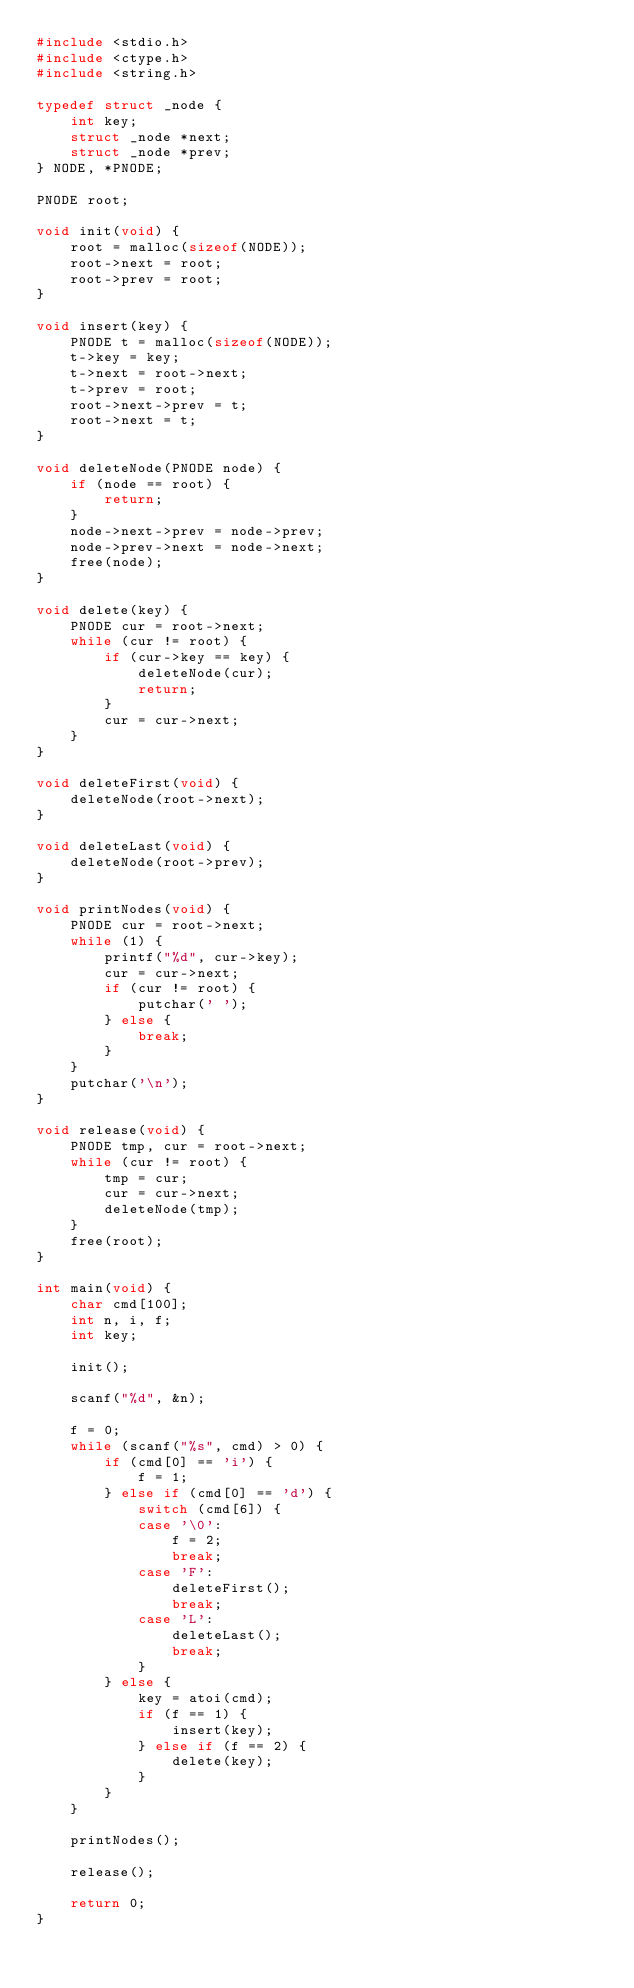<code> <loc_0><loc_0><loc_500><loc_500><_C_>#include <stdio.h>
#include <ctype.h>
#include <string.h>

typedef struct _node {
	int key;
	struct _node *next;
	struct _node *prev;
} NODE, *PNODE;

PNODE root;

void init(void) {
	root = malloc(sizeof(NODE));
	root->next = root;
	root->prev = root;
}

void insert(key) {
	PNODE t = malloc(sizeof(NODE));
	t->key = key;
	t->next = root->next;
	t->prev = root;
	root->next->prev = t;
	root->next = t;
}

void deleteNode(PNODE node) {
	if (node == root) {
		return;
	}
	node->next->prev = node->prev;
	node->prev->next = node->next;
	free(node);
}

void delete(key) {
	PNODE cur = root->next;
	while (cur != root) {
		if (cur->key == key) {
			deleteNode(cur);
			return;
		}
		cur = cur->next;
	}
}

void deleteFirst(void) {
	deleteNode(root->next);
}

void deleteLast(void) {
	deleteNode(root->prev);
}

void printNodes(void) {
	PNODE cur = root->next;
	while (1) {
		printf("%d", cur->key);
		cur = cur->next;
		if (cur != root) {
			putchar(' ');
		} else {
			break;
		}
	}
	putchar('\n');
}

void release(void) {
	PNODE tmp, cur = root->next;
	while (cur != root) {
		tmp = cur;
		cur = cur->next;
		deleteNode(tmp);		
	}
	free(root);
} 

int main(void) {
	char cmd[100];
	int n, i, f;
	int key;
	
	init();	
	
	scanf("%d", &n);
	
	f = 0;
	while (scanf("%s", cmd) > 0) {
		if (cmd[0] == 'i') {
			f = 1;
		} else if (cmd[0] == 'd') {
			switch (cmd[6]) {
			case '\0':
				f = 2;
				break;
			case 'F':
				deleteFirst();
				break;
			case 'L':
				deleteLast();
				break;
			}
		} else {
			key = atoi(cmd);
			if (f == 1) {
				insert(key);
			} else if (f == 2) {
				delete(key);
			}
		}
	}
	
	printNodes();
	
	release();
	
	return 0;
}</code> 